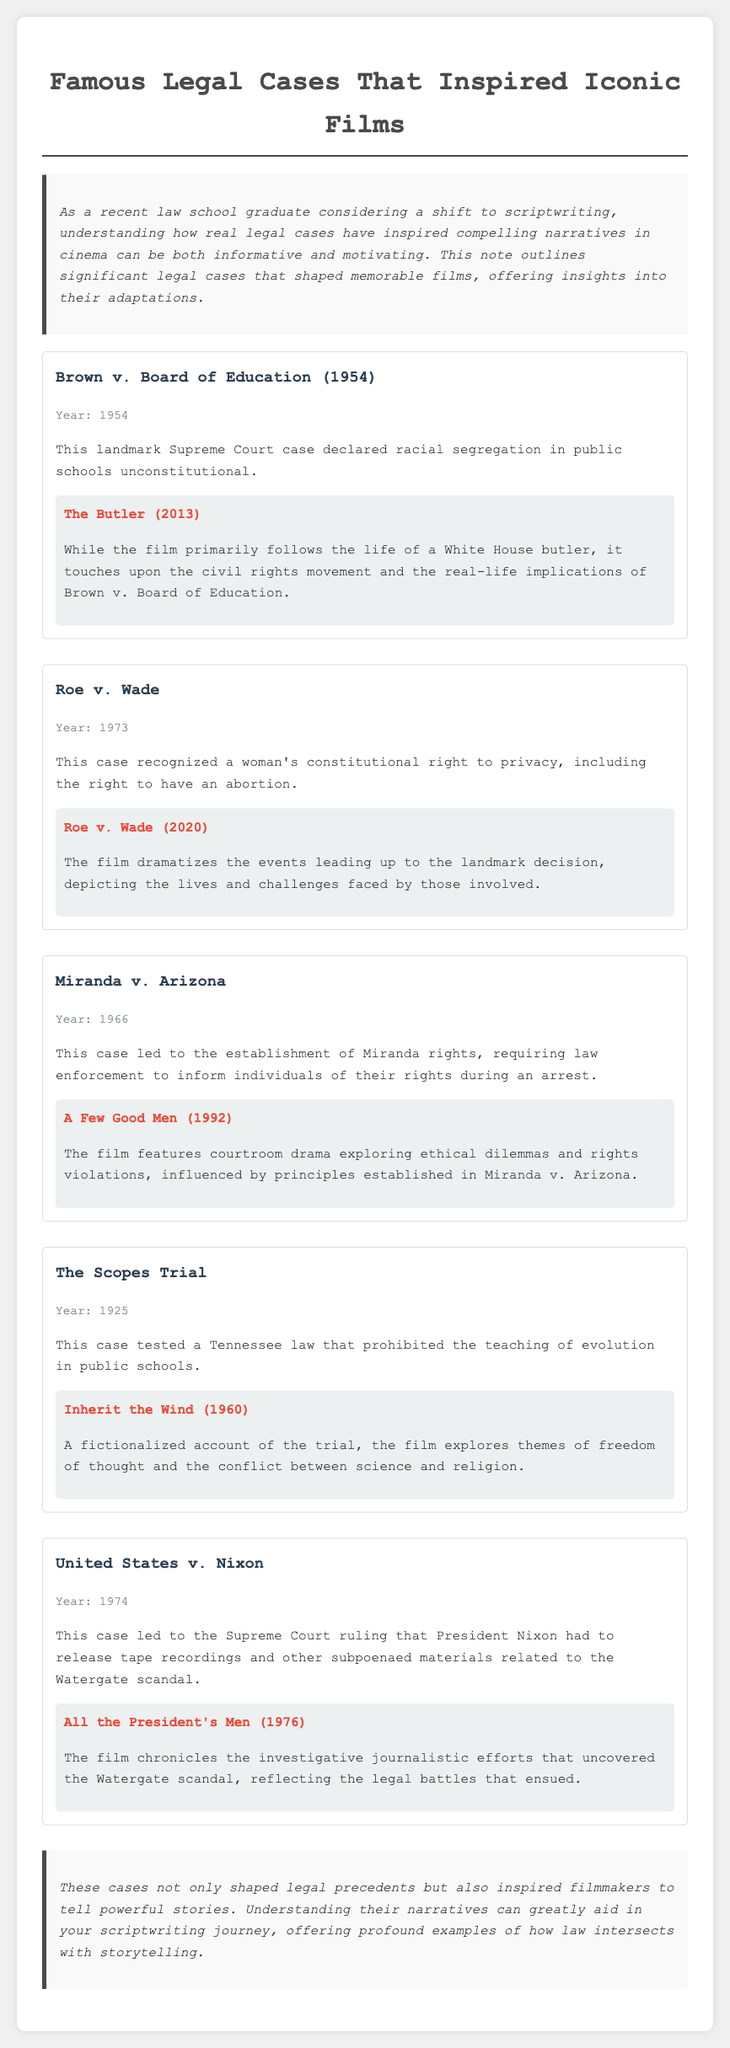What is the landmark Supreme Court case that declared racial segregation in public schools unconstitutional? The document states that Brown v. Board of Education (1954) is the case that declared racial segregation in public schools unconstitutional.
Answer: Brown v. Board of Education In what year did Roe v. Wade occur? The document provides the year for Roe v. Wade as 1973.
Answer: 1973 Which film dramatizes the events leading up to the Roe v. Wade decision? The document mentions the film Roe v. Wade (2020) as the adaptation of this case.
Answer: Roe v. Wade (2020) What legal principle was established as a result of Miranda v. Arizona? According to the note, Miranda v. Arizona led to the establishment of Miranda rights.
Answer: Miranda rights Which movie chronicles the investigative journalism related to the Watergate scandal? The document specifies All the President's Men (1976) as the film that chronicles this investigative journalism.
Answer: All the President's Men (1976) How many famous legal cases are discussed in the document? The document outlines five famous legal cases that inspired iconic films.
Answer: Five What major theme is explored in the film Inherit the Wind? The document states that Inherit the Wind explores themes of freedom of thought and the conflict between science and religion.
Answer: Freedom of thought and the conflict between science and religion What type of narrative does the conclusion of the document suggest these cases have? The conclusion indicates that these cases inspired filmmakers to tell powerful stories.
Answer: Powerful stories What is the purpose of the introductory section in the document? The introduction explains the relevance of real legal cases to scriptwriting for recent law graduates.
Answer: Relevance to scriptwriting 